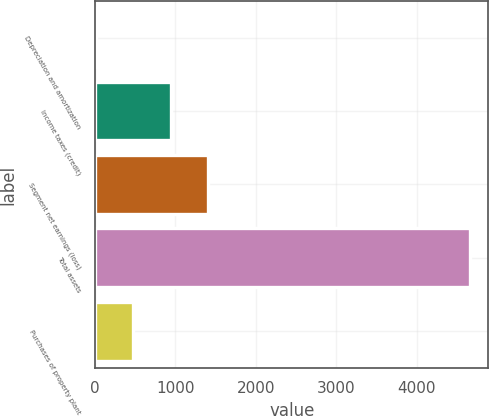<chart> <loc_0><loc_0><loc_500><loc_500><bar_chart><fcel>Depreciation and amortization<fcel>Income taxes (credit)<fcel>Segment net earnings (loss)<fcel>Total assets<fcel>Purchases of property plant<nl><fcel>9.8<fcel>939.76<fcel>1404.74<fcel>4659.6<fcel>474.78<nl></chart> 